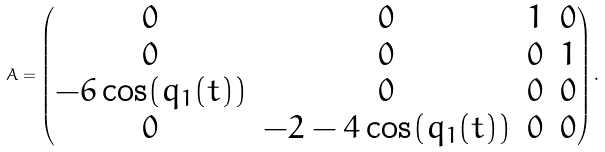<formula> <loc_0><loc_0><loc_500><loc_500>A = \begin{pmatrix} 0 & 0 & 1 & 0 \\ 0 & 0 & 0 & 1 \\ - 6 \cos ( q _ { 1 } ( t ) ) & 0 & 0 & 0 \\ 0 & - 2 - 4 \cos ( q _ { 1 } ( t ) ) & 0 & 0 \end{pmatrix} .</formula> 